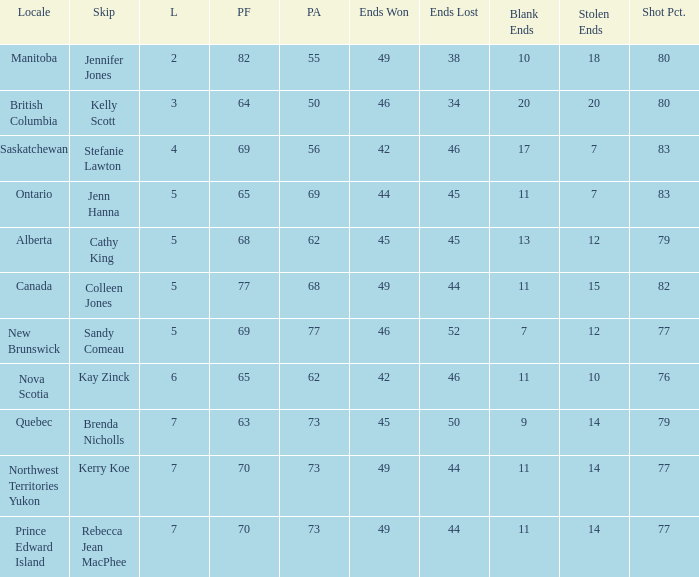What is the PA when the PF is 77? 68.0. 